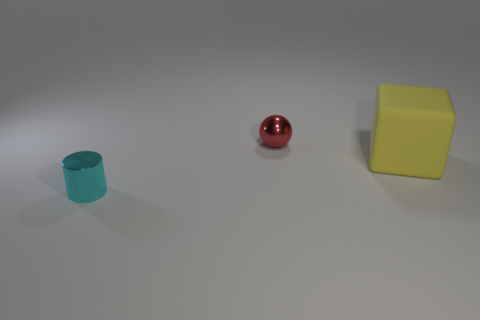Add 1 tiny blue metal objects. How many objects exist? 4 Add 1 large yellow rubber cubes. How many large yellow rubber cubes are left? 2 Add 2 small yellow rubber blocks. How many small yellow rubber blocks exist? 2 Subtract 0 green cubes. How many objects are left? 3 Subtract all blocks. How many objects are left? 2 Subtract 1 blocks. How many blocks are left? 0 Subtract all brown blocks. Subtract all gray balls. How many blocks are left? 1 Subtract all green blocks. How many green cylinders are left? 0 Subtract all cyan metal things. Subtract all large yellow metal spheres. How many objects are left? 2 